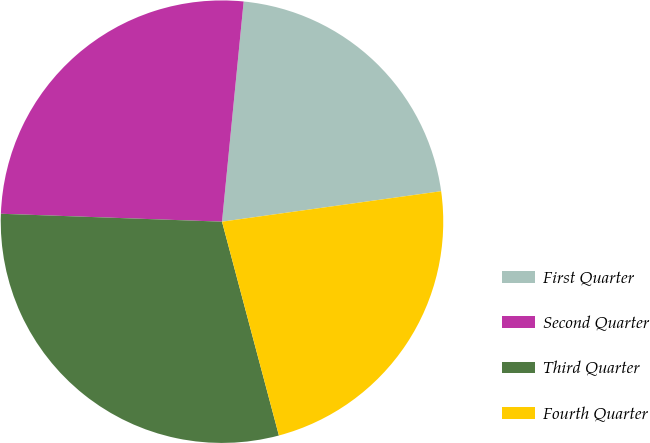Convert chart to OTSL. <chart><loc_0><loc_0><loc_500><loc_500><pie_chart><fcel>First Quarter<fcel>Second Quarter<fcel>Third Quarter<fcel>Fourth Quarter<nl><fcel>21.24%<fcel>25.99%<fcel>29.71%<fcel>23.06%<nl></chart> 